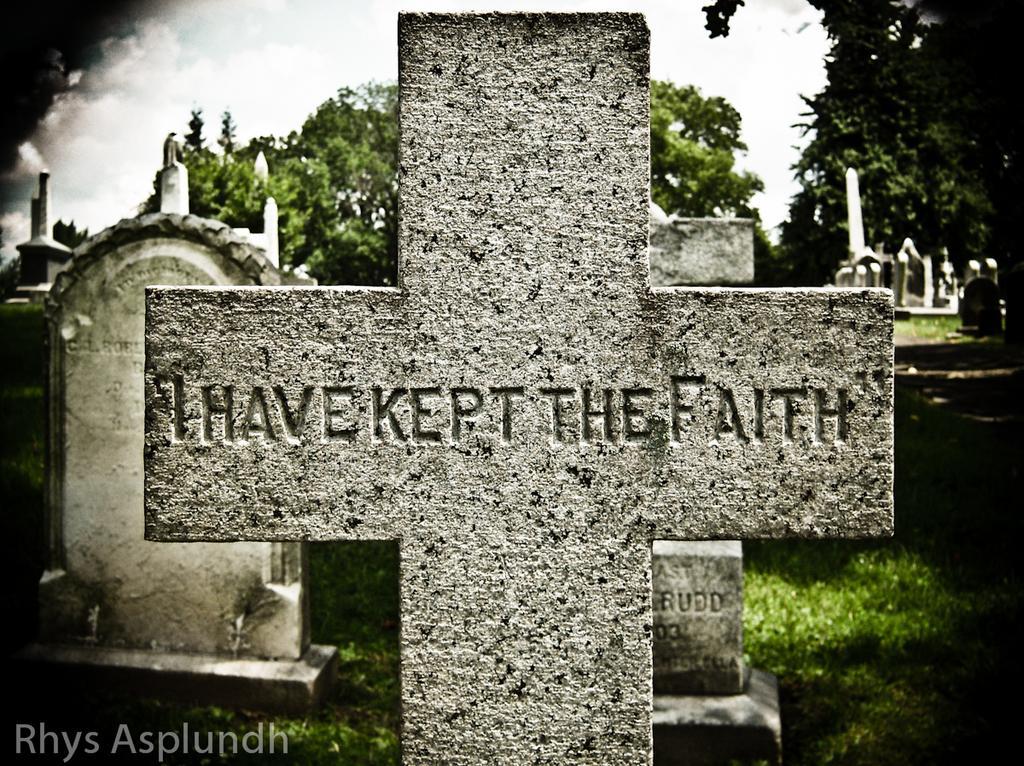Could you give a brief overview of what you see in this image? In this image, we can see graves and in the background, there are trees. At the bottom, there is ground covered with grass and we can see some text. At the top, there are clouds in the sky. 